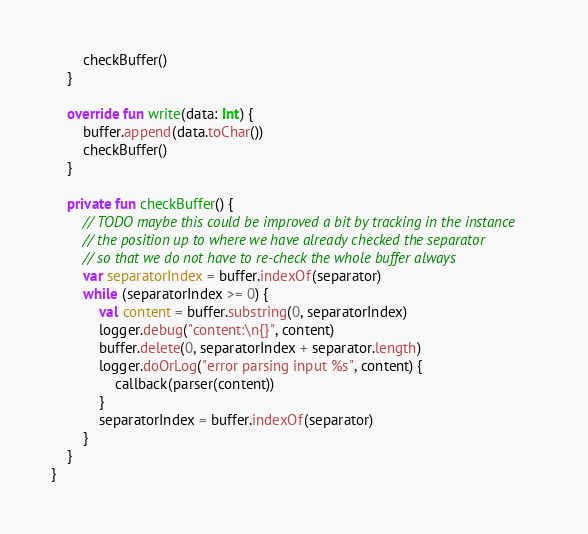<code> <loc_0><loc_0><loc_500><loc_500><_Kotlin_>		checkBuffer()
	}

	override fun write(data: Int) {
		buffer.append(data.toChar())
		checkBuffer()
	}

	private fun checkBuffer() {
		// TODO maybe this could be improved a bit by tracking in the instance
		// the position up to where we have already checked the separator
		// so that we do not have to re-check the whole buffer always
		var separatorIndex = buffer.indexOf(separator)
		while (separatorIndex >= 0) {
			val content = buffer.substring(0, separatorIndex)
			logger.debug("content:\n{}", content)
			buffer.delete(0, separatorIndex + separator.length)
			logger.doOrLog("error parsing input %s", content) {
				callback(parser(content))
			}
			separatorIndex = buffer.indexOf(separator)
		}
	}
}</code> 